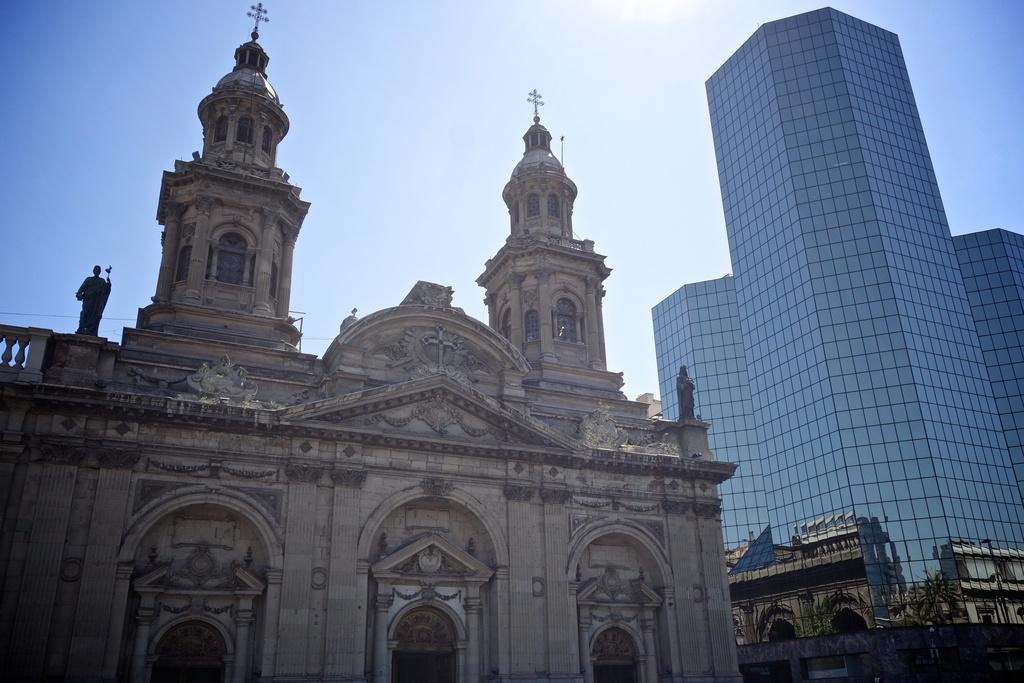What type of structures can be seen in the image? There are buildings in the image. Are there any decorative elements on the buildings? Yes, there are statues on the buildings. What religious symbols are present on the buildings? Cross symbols are present on the buildings. What can be seen in the background of the image? The sky is visible in the background of the image. What type of wrench is being used to trim the bushes in the image? There are no bushes or wrenches present in the image; it features buildings with statues and cross symbols. 